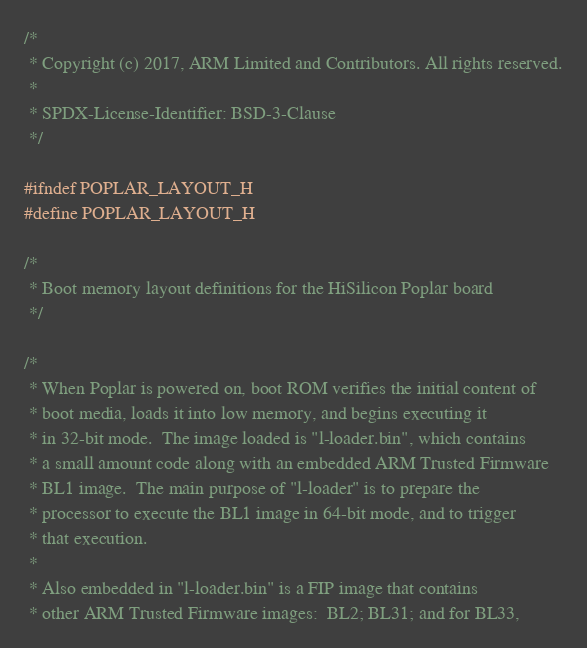Convert code to text. <code><loc_0><loc_0><loc_500><loc_500><_C_>/*
 * Copyright (c) 2017, ARM Limited and Contributors. All rights reserved.
 *
 * SPDX-License-Identifier: BSD-3-Clause
 */

#ifndef POPLAR_LAYOUT_H
#define POPLAR_LAYOUT_H

/*
 * Boot memory layout definitions for the HiSilicon Poplar board
 */

/*
 * When Poplar is powered on, boot ROM verifies the initial content of
 * boot media, loads it into low memory, and begins executing it
 * in 32-bit mode.  The image loaded is "l-loader.bin", which contains
 * a small amount code along with an embedded ARM Trusted Firmware
 * BL1 image.  The main purpose of "l-loader" is to prepare the
 * processor to execute the BL1 image in 64-bit mode, and to trigger
 * that execution.
 *
 * Also embedded in "l-loader.bin" is a FIP image that contains
 * other ARM Trusted Firmware images:  BL2; BL31; and for BL33,</code> 